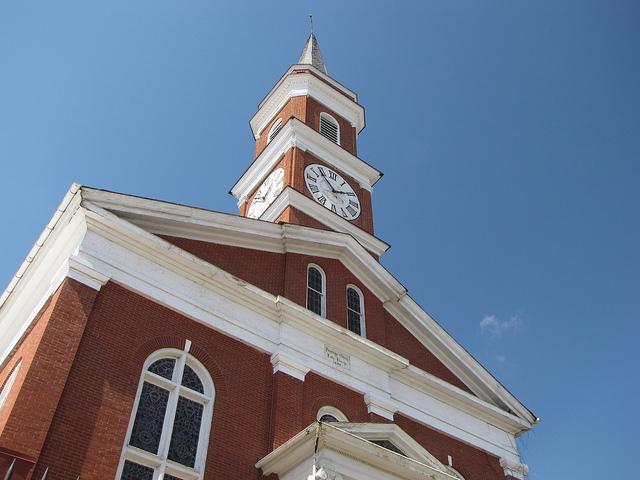What color is the sky?
Concise answer only. Blue. Is there a balcony?
Be succinct. No. What time does the clock have?
Be succinct. 1:55. Is the sky clear?
Keep it brief. Yes. 